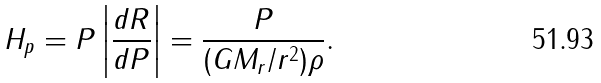Convert formula to latex. <formula><loc_0><loc_0><loc_500><loc_500>H _ { p } = P \left | \frac { d R } { d P } \right | = \frac { P } { ( G M _ { r } / r ^ { 2 } ) \rho } .</formula> 